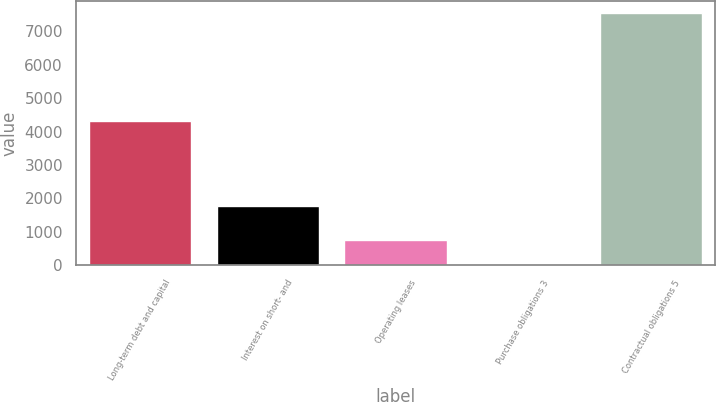Convert chart to OTSL. <chart><loc_0><loc_0><loc_500><loc_500><bar_chart><fcel>Long-term debt and capital<fcel>Interest on short- and<fcel>Operating leases<fcel>Purchase obligations 3<fcel>Contractual obligations 5<nl><fcel>4328<fcel>1766<fcel>762.5<fcel>10<fcel>7535<nl></chart> 